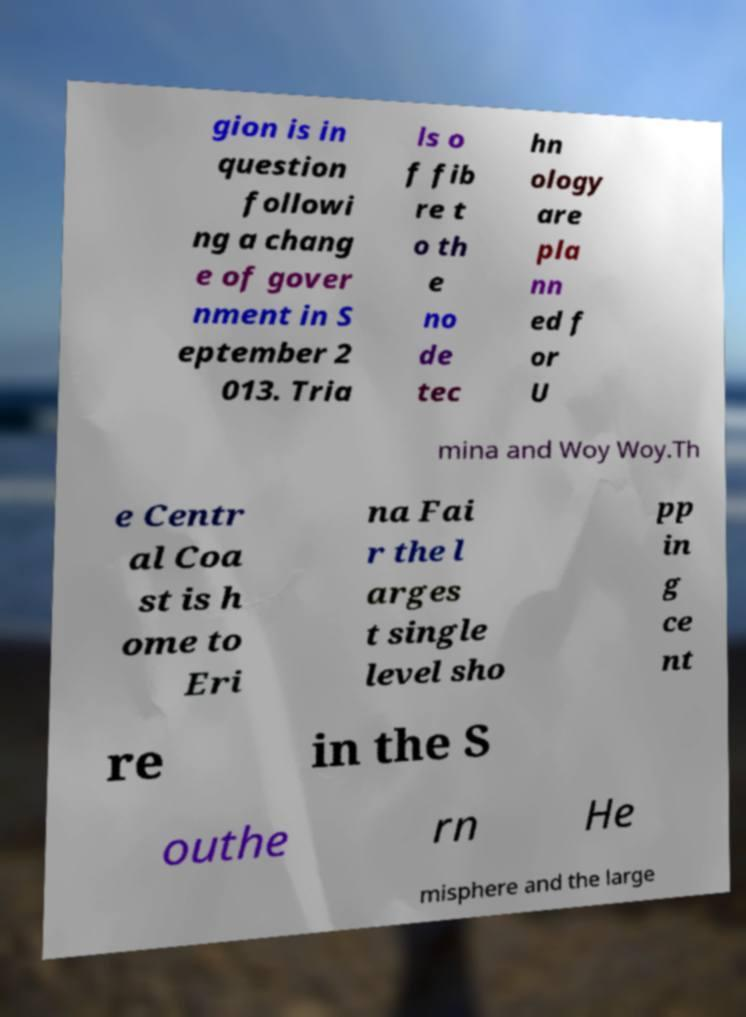Could you assist in decoding the text presented in this image and type it out clearly? gion is in question followi ng a chang e of gover nment in S eptember 2 013. Tria ls o f fib re t o th e no de tec hn ology are pla nn ed f or U mina and Woy Woy.Th e Centr al Coa st is h ome to Eri na Fai r the l arges t single level sho pp in g ce nt re in the S outhe rn He misphere and the large 